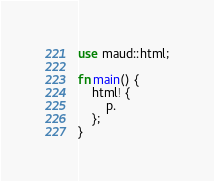<code> <loc_0><loc_0><loc_500><loc_500><_Rust_>use maud::html;

fn main() {
    html! {
        p.
    };
}
</code> 